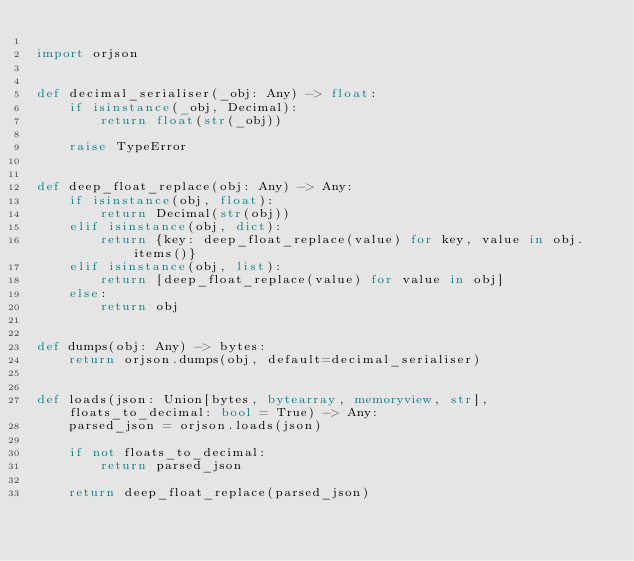<code> <loc_0><loc_0><loc_500><loc_500><_Python_>
import orjson


def decimal_serialiser(_obj: Any) -> float:
    if isinstance(_obj, Decimal):
        return float(str(_obj))

    raise TypeError


def deep_float_replace(obj: Any) -> Any:
    if isinstance(obj, float):
        return Decimal(str(obj))
    elif isinstance(obj, dict):
        return {key: deep_float_replace(value) for key, value in obj.items()}
    elif isinstance(obj, list):
        return [deep_float_replace(value) for value in obj]
    else:
        return obj


def dumps(obj: Any) -> bytes:
    return orjson.dumps(obj, default=decimal_serialiser)


def loads(json: Union[bytes, bytearray, memoryview, str], floats_to_decimal: bool = True) -> Any:
    parsed_json = orjson.loads(json)

    if not floats_to_decimal:
        return parsed_json

    return deep_float_replace(parsed_json)
</code> 